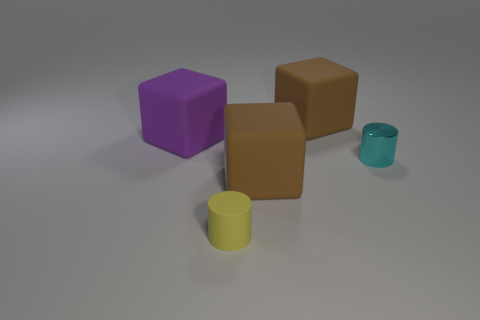Subtract all gray spheres. How many brown cubes are left? 2 Subtract all big purple matte cubes. How many cubes are left? 2 Add 3 tiny yellow cylinders. How many objects exist? 8 Subtract all cylinders. How many objects are left? 3 Subtract all rubber cubes. Subtract all purple objects. How many objects are left? 1 Add 3 big cubes. How many big cubes are left? 6 Add 5 small cyan objects. How many small cyan objects exist? 6 Subtract 1 yellow cylinders. How many objects are left? 4 